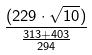Convert formula to latex. <formula><loc_0><loc_0><loc_500><loc_500>\frac { ( 2 2 9 \cdot \sqrt { 1 0 } ) } { \frac { 3 1 3 + 4 0 3 } { 2 9 4 } }</formula> 